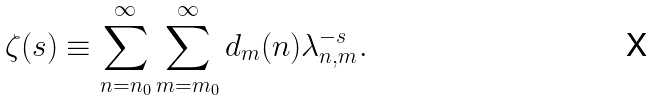<formula> <loc_0><loc_0><loc_500><loc_500>\zeta ( s ) \equiv \sum _ { n = n _ { 0 } } ^ { \infty } \sum _ { m = m _ { 0 } } ^ { \infty } d _ { m } ( n ) \lambda _ { n , m } ^ { - s } .</formula> 